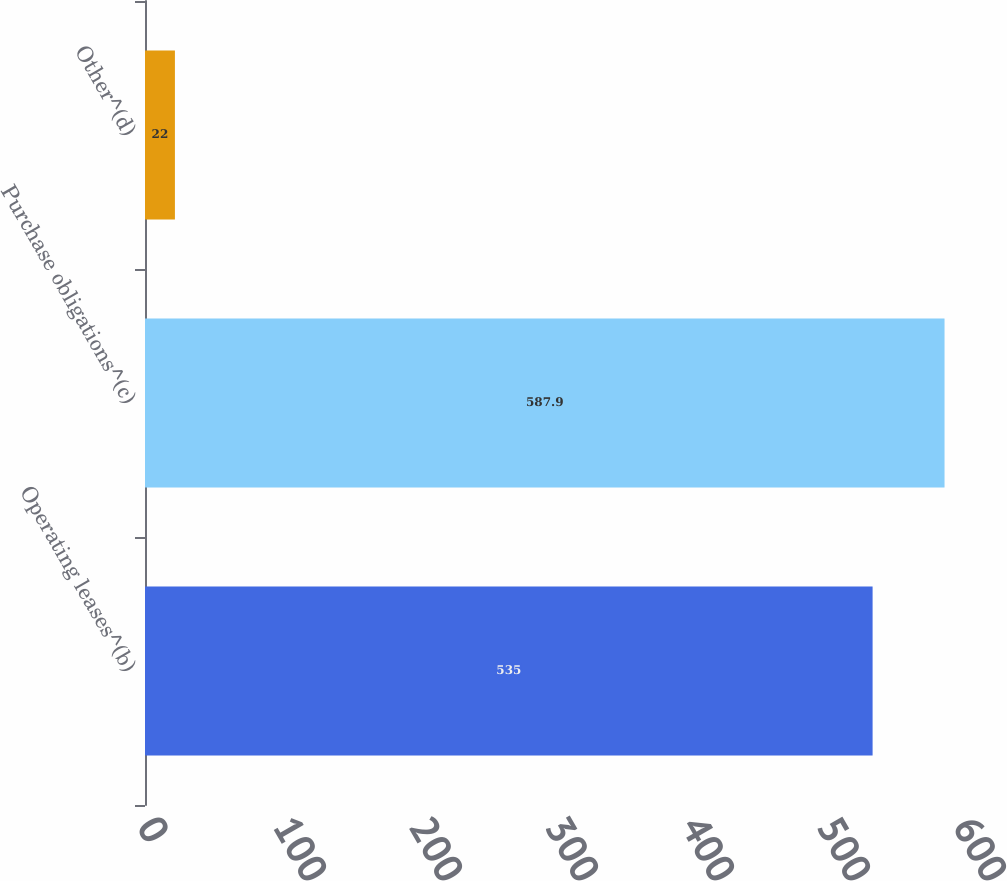Convert chart to OTSL. <chart><loc_0><loc_0><loc_500><loc_500><bar_chart><fcel>Operating leases^(b)<fcel>Purchase obligations^(c)<fcel>Other^(d)<nl><fcel>535<fcel>587.9<fcel>22<nl></chart> 